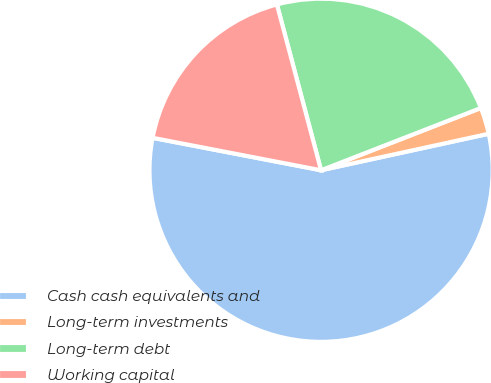<chart> <loc_0><loc_0><loc_500><loc_500><pie_chart><fcel>Cash cash equivalents and<fcel>Long-term investments<fcel>Long-term debt<fcel>Working capital<nl><fcel>56.44%<fcel>2.5%<fcel>23.23%<fcel>17.83%<nl></chart> 